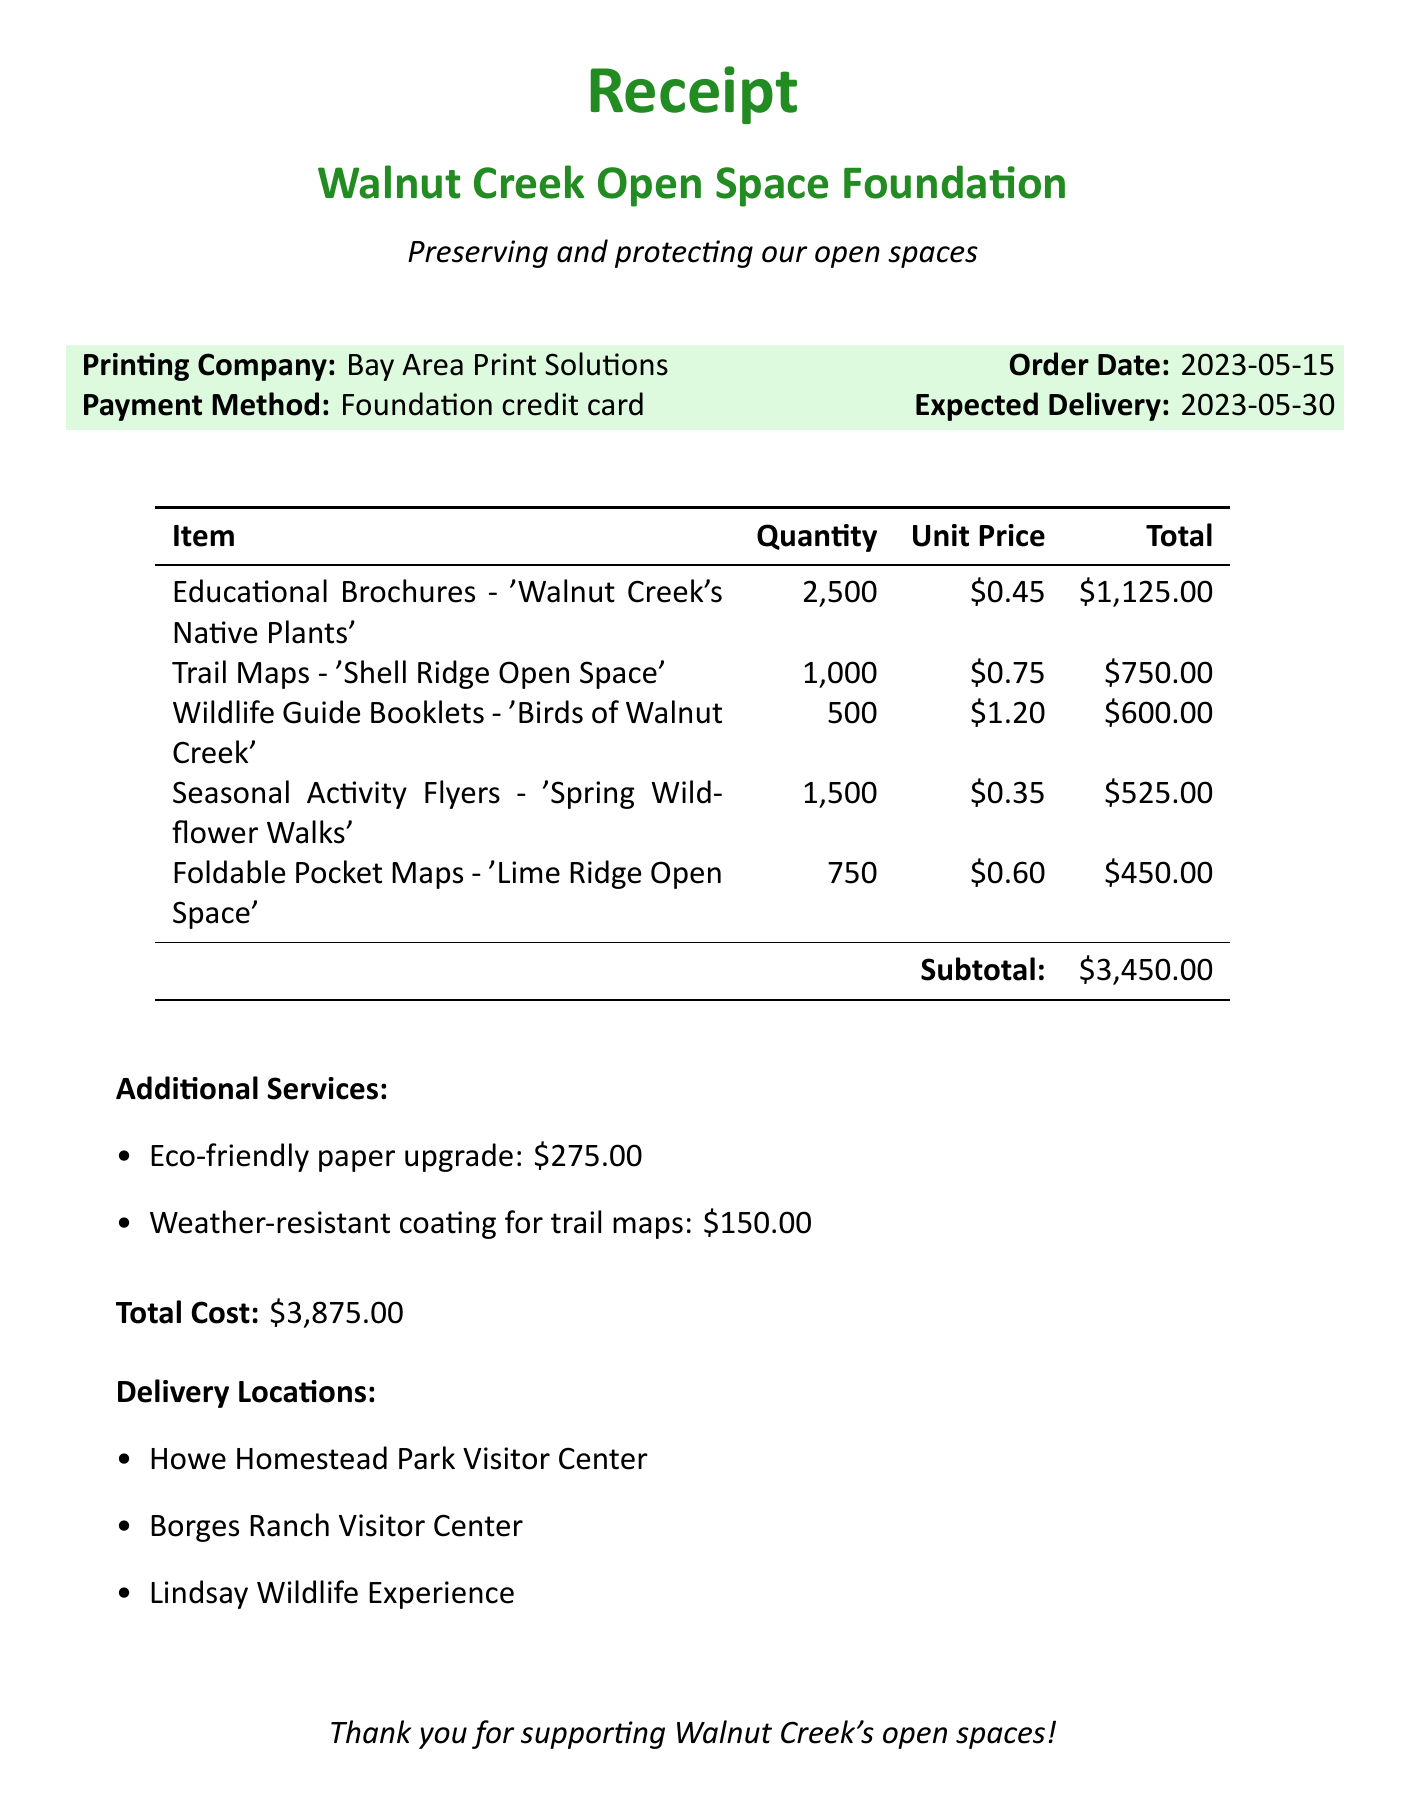What is the name of the printing company? The name of the printing company is listed in the document under "Printing Company."
Answer: Bay Area Print Solutions What is the total cost of the printing expenses? The total cost of the printing expenses is specified at the end of the document.
Answer: $3,875.00 What is the quantity of Trail Maps printed? The quantity of Trail Maps is provided in the list of items.
Answer: 1,000 What additional service was provided for the trail maps? The document mentions a specific additional service related to trail maps.
Answer: Weather-resistant coating for trail maps What is the unit price of the Educational Brochures? The unit price of Educational Brochures can be found in the itemization section.
Answer: $0.45 How many locations are the printed materials being delivered to? The document lists the delivery locations, which indicates the number of locations.
Answer: 3 What was the order date? The order date is mentioned in the order details section of the document.
Answer: 2023-05-15 How many Foldable Pocket Maps were printed? The specific quantity for Foldable Pocket Maps is stated under items.
Answer: 750 What is one of the titles of the educational brochures? The document specifies a title for the Educational Brochures in the list.
Answer: Walnut Creek's Native Plants 